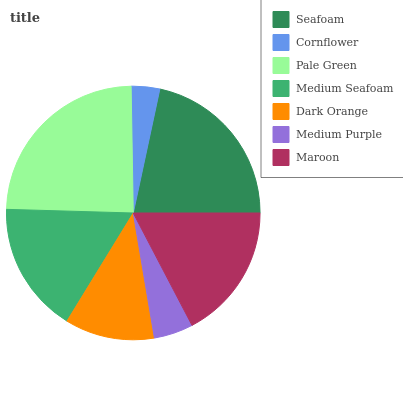Is Cornflower the minimum?
Answer yes or no. Yes. Is Pale Green the maximum?
Answer yes or no. Yes. Is Pale Green the minimum?
Answer yes or no. No. Is Cornflower the maximum?
Answer yes or no. No. Is Pale Green greater than Cornflower?
Answer yes or no. Yes. Is Cornflower less than Pale Green?
Answer yes or no. Yes. Is Cornflower greater than Pale Green?
Answer yes or no. No. Is Pale Green less than Cornflower?
Answer yes or no. No. Is Medium Seafoam the high median?
Answer yes or no. Yes. Is Medium Seafoam the low median?
Answer yes or no. Yes. Is Cornflower the high median?
Answer yes or no. No. Is Dark Orange the low median?
Answer yes or no. No. 